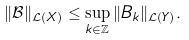Convert formula to latex. <formula><loc_0><loc_0><loc_500><loc_500>\| \mathcal { B } \| _ { \mathcal { L } ( X ) } \leq \sup _ { k \in \mathbb { Z } } \| B _ { k } \| _ { \mathcal { L } ( Y ) } .</formula> 